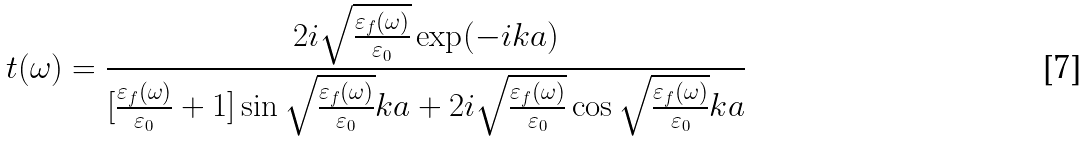Convert formula to latex. <formula><loc_0><loc_0><loc_500><loc_500>t ( \omega ) = \frac { 2 i \sqrt { \frac { \varepsilon _ { f } ( \omega ) } { \varepsilon _ { 0 } } } \exp ( - i k a ) } { [ \frac { \varepsilon _ { f } ( \omega ) } { \varepsilon _ { 0 } } + 1 ] \sin \sqrt { \frac { \varepsilon _ { f } ( \omega ) } { \varepsilon _ { 0 } } } k a + 2 i \sqrt { \frac { \varepsilon _ { f } ( \omega ) } { \varepsilon _ { 0 } } } \cos \sqrt { \frac { \varepsilon _ { f } ( \omega ) } { \varepsilon _ { 0 } } } k a }</formula> 